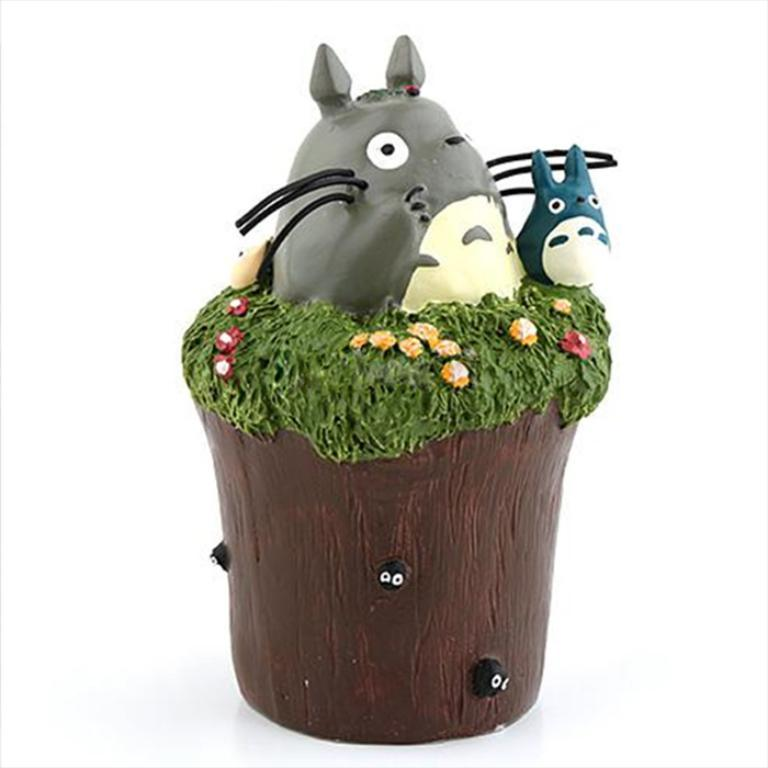What object is the main focus of the image? There is a pot in the image. What else can be seen on the pot? There are two toys on the pot. What color is the background of the image? The background of the image is white. What type of behavior can be observed from the toys in the image? There is no behavior to observe from the toys in the image, as they are inanimate objects. What season is depicted in the image? The provided facts do not give any information about the season, so it cannot be determined from the image. 